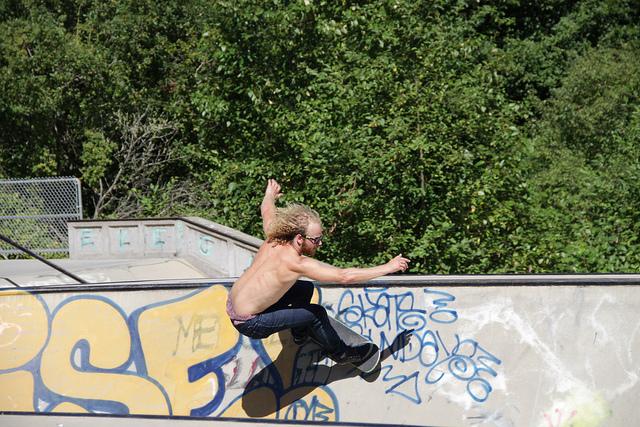Is the man wearing a shirt?
Write a very short answer. No. Is this man wearing any underwear?
Give a very brief answer. Yes. What is written on the wall?
Be succinct. Graffiti. What is the man skating on?
Short answer required. Wall. 